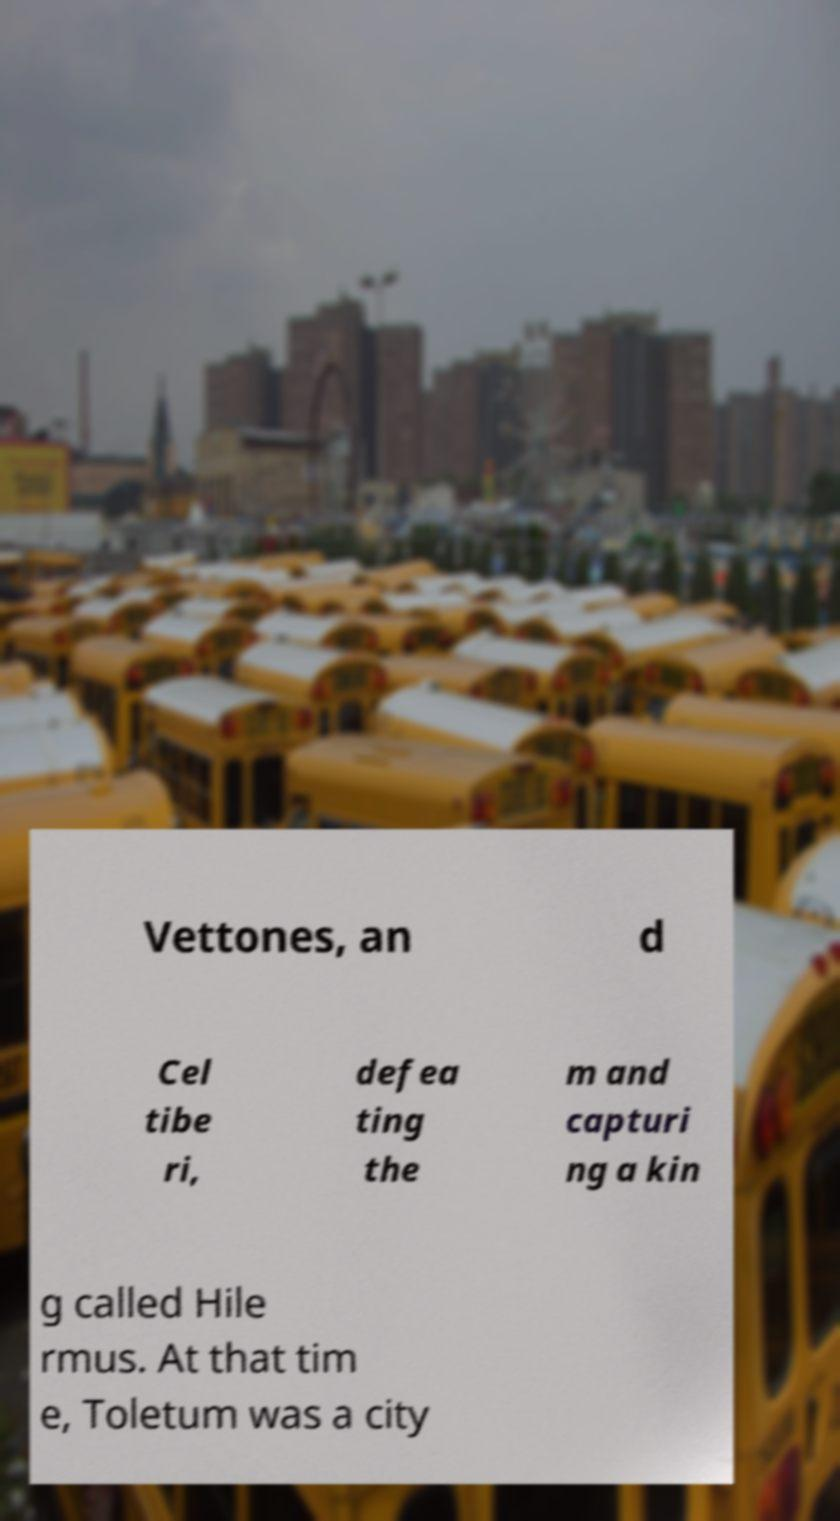There's text embedded in this image that I need extracted. Can you transcribe it verbatim? Vettones, an d Cel tibe ri, defea ting the m and capturi ng a kin g called Hile rmus. At that tim e, Toletum was a city 